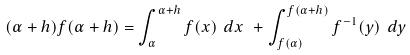Convert formula to latex. <formula><loc_0><loc_0><loc_500><loc_500>( \alpha + h ) f ( \alpha + h ) = \int _ { \alpha } ^ { \alpha + h } f ( x ) \ d x \ + \int _ { f ( \alpha ) } ^ { f ( \alpha + h ) } f ^ { - 1 } ( y ) \ d y \</formula> 